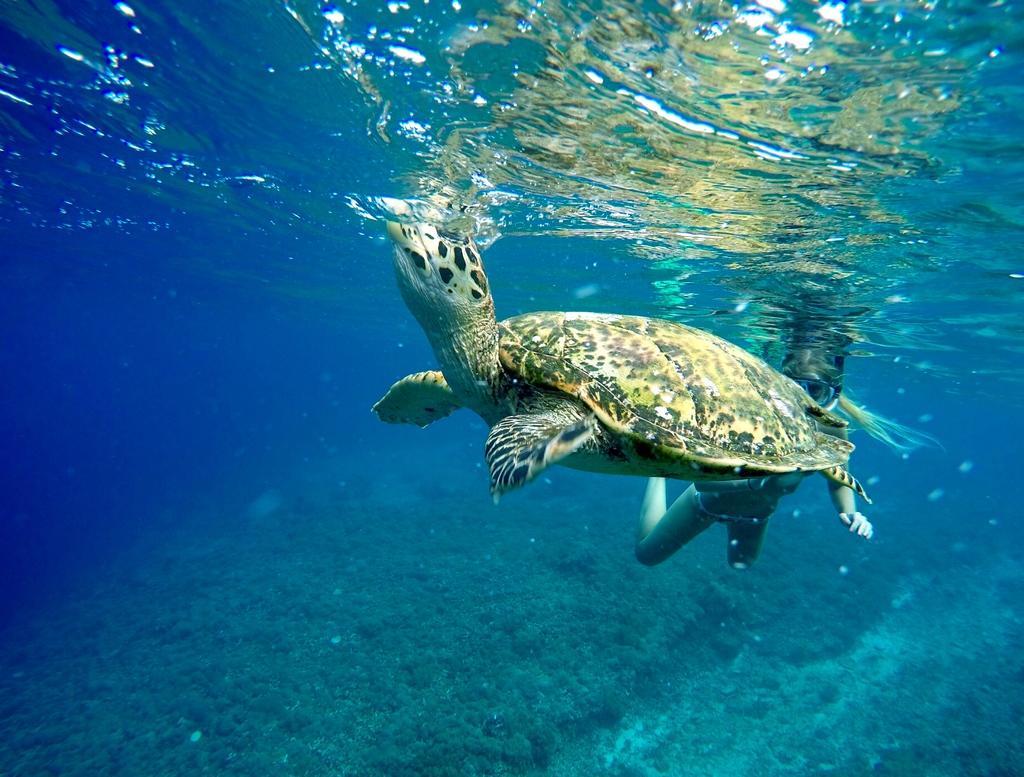Describe this image in one or two sentences. In this picture I can see a turtle and a person in the water. 